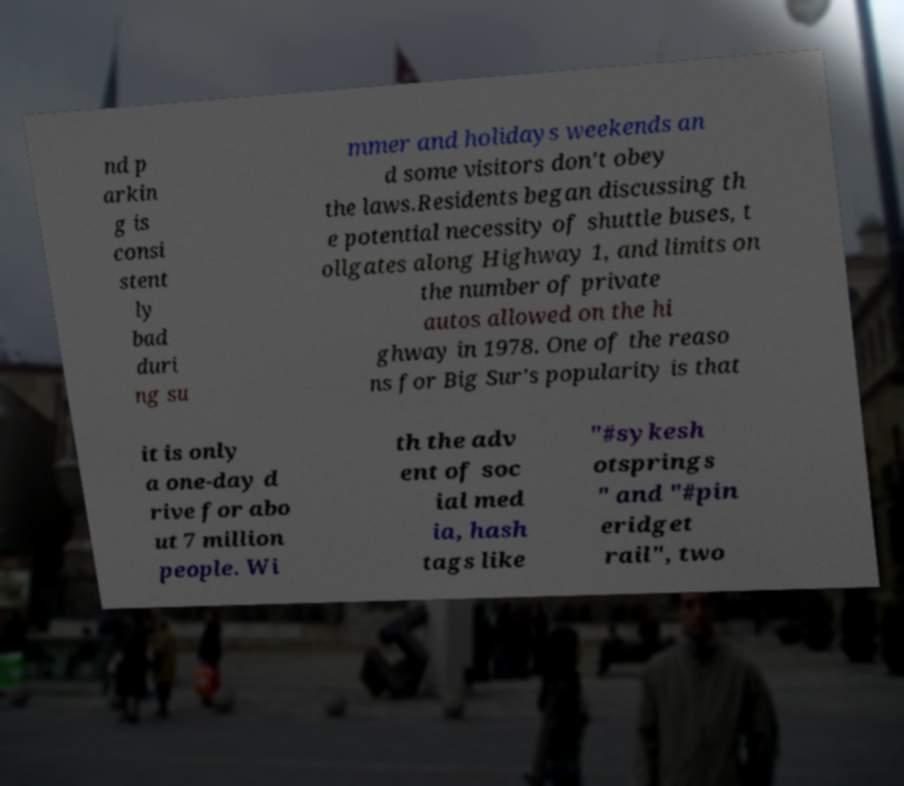I need the written content from this picture converted into text. Can you do that? nd p arkin g is consi stent ly bad duri ng su mmer and holidays weekends an d some visitors don't obey the laws.Residents began discussing th e potential necessity of shuttle buses, t ollgates along Highway 1, and limits on the number of private autos allowed on the hi ghway in 1978. One of the reaso ns for Big Sur's popularity is that it is only a one-day d rive for abo ut 7 million people. Wi th the adv ent of soc ial med ia, hash tags like "#sykesh otsprings " and "#pin eridget rail", two 